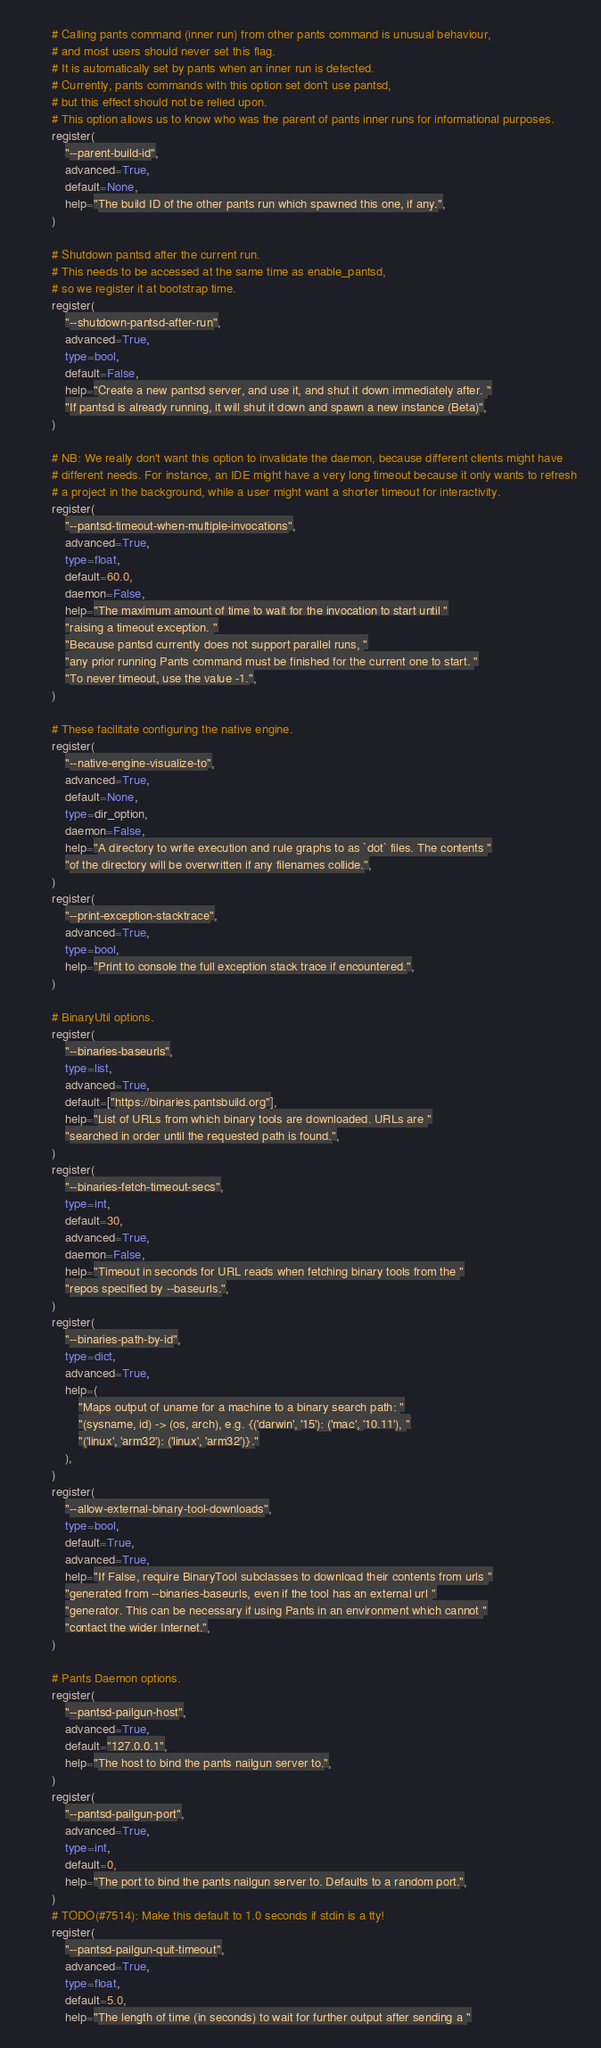Convert code to text. <code><loc_0><loc_0><loc_500><loc_500><_Python_>
        # Calling pants command (inner run) from other pants command is unusual behaviour,
        # and most users should never set this flag.
        # It is automatically set by pants when an inner run is detected.
        # Currently, pants commands with this option set don't use pantsd,
        # but this effect should not be relied upon.
        # This option allows us to know who was the parent of pants inner runs for informational purposes.
        register(
            "--parent-build-id",
            advanced=True,
            default=None,
            help="The build ID of the other pants run which spawned this one, if any.",
        )

        # Shutdown pantsd after the current run.
        # This needs to be accessed at the same time as enable_pantsd,
        # so we register it at bootstrap time.
        register(
            "--shutdown-pantsd-after-run",
            advanced=True,
            type=bool,
            default=False,
            help="Create a new pantsd server, and use it, and shut it down immediately after. "
            "If pantsd is already running, it will shut it down and spawn a new instance (Beta)",
        )

        # NB: We really don't want this option to invalidate the daemon, because different clients might have
        # different needs. For instance, an IDE might have a very long timeout because it only wants to refresh
        # a project in the background, while a user might want a shorter timeout for interactivity.
        register(
            "--pantsd-timeout-when-multiple-invocations",
            advanced=True,
            type=float,
            default=60.0,
            daemon=False,
            help="The maximum amount of time to wait for the invocation to start until "
            "raising a timeout exception. "
            "Because pantsd currently does not support parallel runs, "
            "any prior running Pants command must be finished for the current one to start. "
            "To never timeout, use the value -1.",
        )

        # These facilitate configuring the native engine.
        register(
            "--native-engine-visualize-to",
            advanced=True,
            default=None,
            type=dir_option,
            daemon=False,
            help="A directory to write execution and rule graphs to as `dot` files. The contents "
            "of the directory will be overwritten if any filenames collide.",
        )
        register(
            "--print-exception-stacktrace",
            advanced=True,
            type=bool,
            help="Print to console the full exception stack trace if encountered.",
        )

        # BinaryUtil options.
        register(
            "--binaries-baseurls",
            type=list,
            advanced=True,
            default=["https://binaries.pantsbuild.org"],
            help="List of URLs from which binary tools are downloaded. URLs are "
            "searched in order until the requested path is found.",
        )
        register(
            "--binaries-fetch-timeout-secs",
            type=int,
            default=30,
            advanced=True,
            daemon=False,
            help="Timeout in seconds for URL reads when fetching binary tools from the "
            "repos specified by --baseurls.",
        )
        register(
            "--binaries-path-by-id",
            type=dict,
            advanced=True,
            help=(
                "Maps output of uname for a machine to a binary search path: "
                "(sysname, id) -> (os, arch), e.g. {('darwin', '15'): ('mac', '10.11'), "
                "('linux', 'arm32'): ('linux', 'arm32')}."
            ),
        )
        register(
            "--allow-external-binary-tool-downloads",
            type=bool,
            default=True,
            advanced=True,
            help="If False, require BinaryTool subclasses to download their contents from urls "
            "generated from --binaries-baseurls, even if the tool has an external url "
            "generator. This can be necessary if using Pants in an environment which cannot "
            "contact the wider Internet.",
        )

        # Pants Daemon options.
        register(
            "--pantsd-pailgun-host",
            advanced=True,
            default="127.0.0.1",
            help="The host to bind the pants nailgun server to.",
        )
        register(
            "--pantsd-pailgun-port",
            advanced=True,
            type=int,
            default=0,
            help="The port to bind the pants nailgun server to. Defaults to a random port.",
        )
        # TODO(#7514): Make this default to 1.0 seconds if stdin is a tty!
        register(
            "--pantsd-pailgun-quit-timeout",
            advanced=True,
            type=float,
            default=5.0,
            help="The length of time (in seconds) to wait for further output after sending a "</code> 